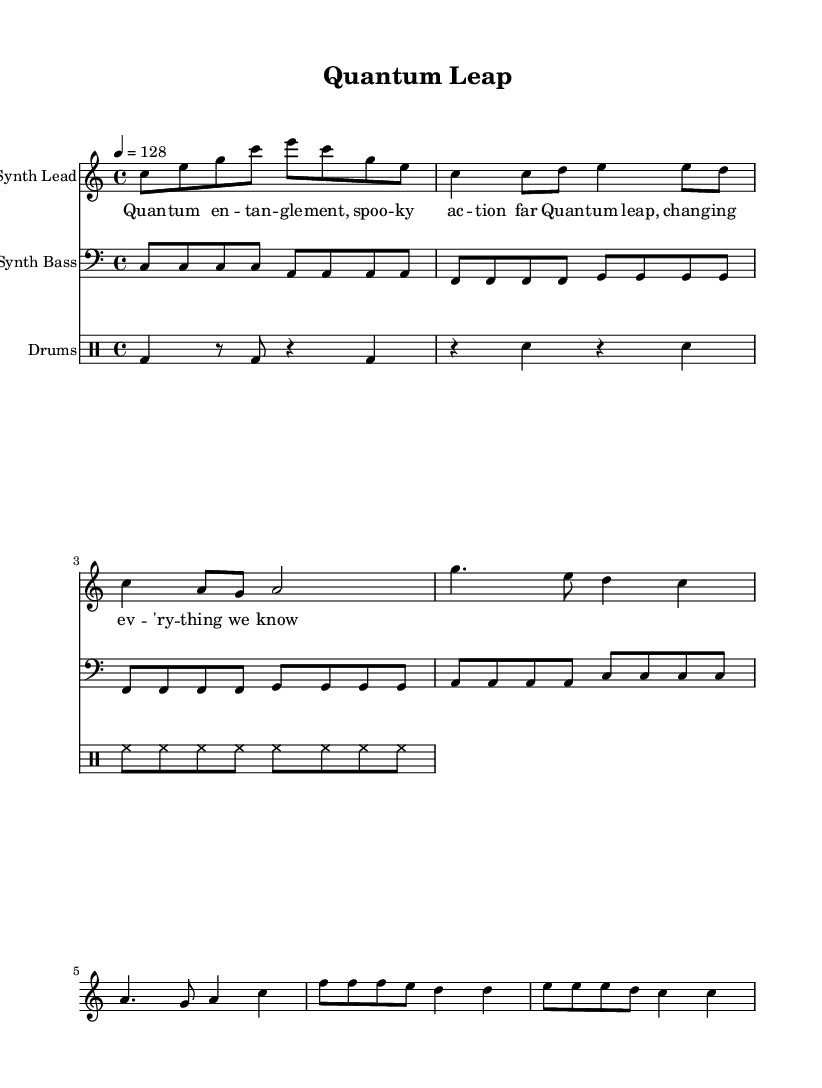What is the key signature of this music? The key signature is shown at the beginning of the score, indicating that the music is in C major, which has no sharps or flats.
Answer: C major What is the time signature of this music? The time signature is noted at the beginning of the score and is written as 4/4, indicating that there are four beats in each measure.
Answer: 4/4 What is the tempo marking for this piece? The tempo marking is indicated at the beginning of the score, specifying a speed of 128 beats per minute.
Answer: 128 How many measures are in the verse section? By carefully analyzing the verse section, the count of the measures can be derived, which shows there are four measures in the verse.
Answer: 4 How many distinct sections does this song have? By examining the structure outlined in the score, there are three distinct sections: the intro, verse, and chorus, in addition to a bridge. The categorization is based on the clear textual and musical divisions present.
Answer: 4 What kind of instruments are featured in this score? The score specifies three instruments: a synthesizer lead, a bass synthesizer, and drums, as indicated by the labels for each staff.
Answer: Synth Lead, Synth Bass, Drums What thematic concept does the lyric introduce in the chorus? The lyrics highlight the scientific theme of quantum leap, referencing profound impacts of scientific breakthroughs, indicating a major concept within the pop music narrative.
Answer: Quantum leap 